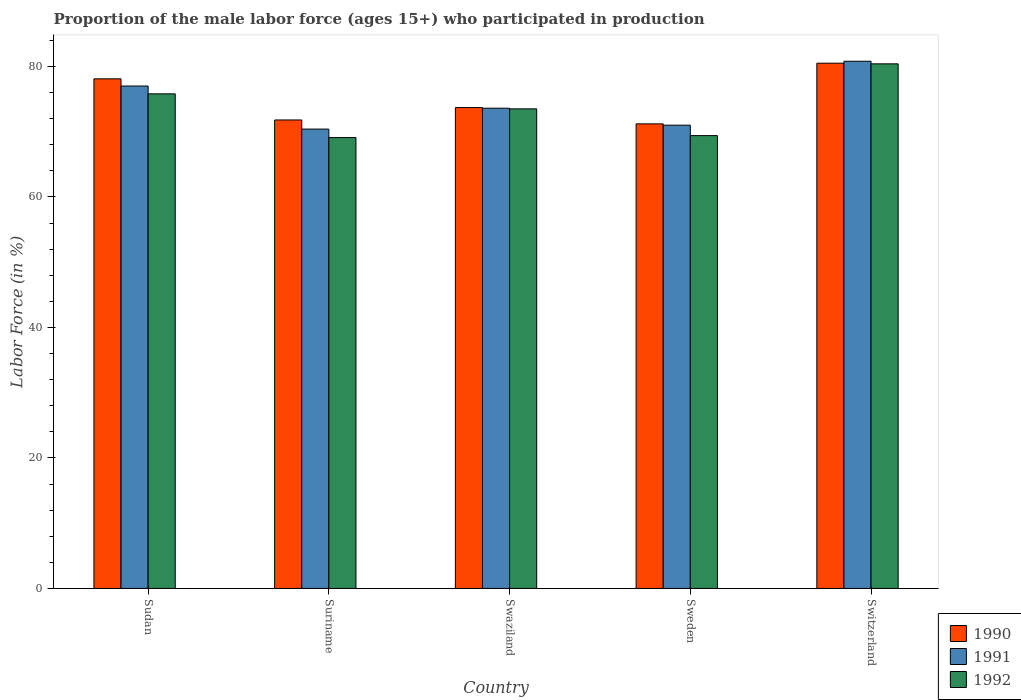How many different coloured bars are there?
Your answer should be very brief. 3. Are the number of bars per tick equal to the number of legend labels?
Offer a terse response. Yes. How many bars are there on the 3rd tick from the right?
Give a very brief answer. 3. What is the label of the 4th group of bars from the left?
Offer a terse response. Sweden. What is the proportion of the male labor force who participated in production in 1991 in Swaziland?
Your answer should be very brief. 73.6. Across all countries, what is the maximum proportion of the male labor force who participated in production in 1991?
Provide a short and direct response. 80.8. Across all countries, what is the minimum proportion of the male labor force who participated in production in 1991?
Give a very brief answer. 70.4. In which country was the proportion of the male labor force who participated in production in 1990 maximum?
Your response must be concise. Switzerland. In which country was the proportion of the male labor force who participated in production in 1991 minimum?
Your answer should be compact. Suriname. What is the total proportion of the male labor force who participated in production in 1992 in the graph?
Give a very brief answer. 368.2. What is the difference between the proportion of the male labor force who participated in production in 1991 in Swaziland and that in Sweden?
Provide a short and direct response. 2.6. What is the difference between the proportion of the male labor force who participated in production in 1990 in Suriname and the proportion of the male labor force who participated in production in 1991 in Sudan?
Your answer should be very brief. -5.2. What is the average proportion of the male labor force who participated in production in 1991 per country?
Your response must be concise. 74.56. What is the difference between the proportion of the male labor force who participated in production of/in 1991 and proportion of the male labor force who participated in production of/in 1992 in Sweden?
Offer a terse response. 1.6. What is the ratio of the proportion of the male labor force who participated in production in 1990 in Swaziland to that in Switzerland?
Make the answer very short. 0.92. Is the proportion of the male labor force who participated in production in 1992 in Swaziland less than that in Switzerland?
Offer a terse response. Yes. What is the difference between the highest and the second highest proportion of the male labor force who participated in production in 1990?
Your answer should be compact. 6.8. What is the difference between the highest and the lowest proportion of the male labor force who participated in production in 1991?
Your answer should be very brief. 10.4. What does the 2nd bar from the left in Sweden represents?
Provide a succinct answer. 1991. What does the 1st bar from the right in Suriname represents?
Ensure brevity in your answer.  1992. How many bars are there?
Your response must be concise. 15. Are all the bars in the graph horizontal?
Keep it short and to the point. No. How many countries are there in the graph?
Keep it short and to the point. 5. Where does the legend appear in the graph?
Ensure brevity in your answer.  Bottom right. What is the title of the graph?
Make the answer very short. Proportion of the male labor force (ages 15+) who participated in production. What is the label or title of the X-axis?
Your answer should be compact. Country. What is the label or title of the Y-axis?
Provide a short and direct response. Labor Force (in %). What is the Labor Force (in %) of 1990 in Sudan?
Make the answer very short. 78.1. What is the Labor Force (in %) in 1991 in Sudan?
Your answer should be compact. 77. What is the Labor Force (in %) in 1992 in Sudan?
Give a very brief answer. 75.8. What is the Labor Force (in %) in 1990 in Suriname?
Keep it short and to the point. 71.8. What is the Labor Force (in %) in 1991 in Suriname?
Provide a short and direct response. 70.4. What is the Labor Force (in %) in 1992 in Suriname?
Keep it short and to the point. 69.1. What is the Labor Force (in %) of 1990 in Swaziland?
Provide a succinct answer. 73.7. What is the Labor Force (in %) of 1991 in Swaziland?
Give a very brief answer. 73.6. What is the Labor Force (in %) in 1992 in Swaziland?
Your answer should be compact. 73.5. What is the Labor Force (in %) in 1990 in Sweden?
Offer a terse response. 71.2. What is the Labor Force (in %) in 1991 in Sweden?
Ensure brevity in your answer.  71. What is the Labor Force (in %) of 1992 in Sweden?
Offer a very short reply. 69.4. What is the Labor Force (in %) of 1990 in Switzerland?
Your answer should be very brief. 80.5. What is the Labor Force (in %) in 1991 in Switzerland?
Your answer should be very brief. 80.8. What is the Labor Force (in %) of 1992 in Switzerland?
Provide a short and direct response. 80.4. Across all countries, what is the maximum Labor Force (in %) of 1990?
Your response must be concise. 80.5. Across all countries, what is the maximum Labor Force (in %) in 1991?
Provide a succinct answer. 80.8. Across all countries, what is the maximum Labor Force (in %) in 1992?
Offer a terse response. 80.4. Across all countries, what is the minimum Labor Force (in %) of 1990?
Offer a very short reply. 71.2. Across all countries, what is the minimum Labor Force (in %) of 1991?
Ensure brevity in your answer.  70.4. Across all countries, what is the minimum Labor Force (in %) of 1992?
Make the answer very short. 69.1. What is the total Labor Force (in %) of 1990 in the graph?
Your answer should be very brief. 375.3. What is the total Labor Force (in %) of 1991 in the graph?
Make the answer very short. 372.8. What is the total Labor Force (in %) of 1992 in the graph?
Your response must be concise. 368.2. What is the difference between the Labor Force (in %) in 1990 in Sudan and that in Suriname?
Ensure brevity in your answer.  6.3. What is the difference between the Labor Force (in %) in 1990 in Sudan and that in Swaziland?
Give a very brief answer. 4.4. What is the difference between the Labor Force (in %) in 1991 in Sudan and that in Switzerland?
Your response must be concise. -3.8. What is the difference between the Labor Force (in %) in 1992 in Sudan and that in Switzerland?
Offer a terse response. -4.6. What is the difference between the Labor Force (in %) of 1990 in Suriname and that in Swaziland?
Keep it short and to the point. -1.9. What is the difference between the Labor Force (in %) in 1991 in Suriname and that in Swaziland?
Keep it short and to the point. -3.2. What is the difference between the Labor Force (in %) in 1992 in Suriname and that in Swaziland?
Provide a short and direct response. -4.4. What is the difference between the Labor Force (in %) in 1990 in Suriname and that in Sweden?
Offer a very short reply. 0.6. What is the difference between the Labor Force (in %) in 1991 in Suriname and that in Sweden?
Make the answer very short. -0.6. What is the difference between the Labor Force (in %) of 1992 in Suriname and that in Sweden?
Make the answer very short. -0.3. What is the difference between the Labor Force (in %) in 1990 in Suriname and that in Switzerland?
Your answer should be very brief. -8.7. What is the difference between the Labor Force (in %) in 1991 in Suriname and that in Switzerland?
Ensure brevity in your answer.  -10.4. What is the difference between the Labor Force (in %) of 1992 in Swaziland and that in Switzerland?
Offer a terse response. -6.9. What is the difference between the Labor Force (in %) in 1990 in Sweden and that in Switzerland?
Your answer should be very brief. -9.3. What is the difference between the Labor Force (in %) of 1992 in Sweden and that in Switzerland?
Your answer should be compact. -11. What is the difference between the Labor Force (in %) of 1990 in Sudan and the Labor Force (in %) of 1991 in Suriname?
Offer a very short reply. 7.7. What is the difference between the Labor Force (in %) of 1990 in Sudan and the Labor Force (in %) of 1992 in Suriname?
Your answer should be compact. 9. What is the difference between the Labor Force (in %) in 1990 in Sudan and the Labor Force (in %) in 1991 in Swaziland?
Offer a very short reply. 4.5. What is the difference between the Labor Force (in %) in 1990 in Sudan and the Labor Force (in %) in 1992 in Swaziland?
Provide a succinct answer. 4.6. What is the difference between the Labor Force (in %) of 1990 in Sudan and the Labor Force (in %) of 1991 in Sweden?
Provide a succinct answer. 7.1. What is the difference between the Labor Force (in %) in 1990 in Sudan and the Labor Force (in %) in 1992 in Sweden?
Provide a short and direct response. 8.7. What is the difference between the Labor Force (in %) in 1991 in Sudan and the Labor Force (in %) in 1992 in Sweden?
Offer a very short reply. 7.6. What is the difference between the Labor Force (in %) in 1990 in Sudan and the Labor Force (in %) in 1991 in Switzerland?
Ensure brevity in your answer.  -2.7. What is the difference between the Labor Force (in %) of 1990 in Suriname and the Labor Force (in %) of 1992 in Swaziland?
Offer a very short reply. -1.7. What is the difference between the Labor Force (in %) of 1991 in Suriname and the Labor Force (in %) of 1992 in Swaziland?
Your response must be concise. -3.1. What is the difference between the Labor Force (in %) in 1991 in Suriname and the Labor Force (in %) in 1992 in Sweden?
Your response must be concise. 1. What is the difference between the Labor Force (in %) of 1990 in Swaziland and the Labor Force (in %) of 1992 in Sweden?
Ensure brevity in your answer.  4.3. What is the difference between the Labor Force (in %) in 1991 in Swaziland and the Labor Force (in %) in 1992 in Sweden?
Make the answer very short. 4.2. What is the difference between the Labor Force (in %) of 1990 in Swaziland and the Labor Force (in %) of 1991 in Switzerland?
Provide a succinct answer. -7.1. What is the difference between the Labor Force (in %) in 1991 in Swaziland and the Labor Force (in %) in 1992 in Switzerland?
Your answer should be very brief. -6.8. What is the difference between the Labor Force (in %) of 1990 in Sweden and the Labor Force (in %) of 1991 in Switzerland?
Offer a very short reply. -9.6. What is the difference between the Labor Force (in %) in 1991 in Sweden and the Labor Force (in %) in 1992 in Switzerland?
Keep it short and to the point. -9.4. What is the average Labor Force (in %) of 1990 per country?
Give a very brief answer. 75.06. What is the average Labor Force (in %) in 1991 per country?
Provide a short and direct response. 74.56. What is the average Labor Force (in %) of 1992 per country?
Your answer should be compact. 73.64. What is the difference between the Labor Force (in %) in 1990 and Labor Force (in %) in 1992 in Sudan?
Offer a very short reply. 2.3. What is the difference between the Labor Force (in %) in 1990 and Labor Force (in %) in 1991 in Suriname?
Your answer should be very brief. 1.4. What is the difference between the Labor Force (in %) of 1990 and Labor Force (in %) of 1992 in Suriname?
Your answer should be compact. 2.7. What is the difference between the Labor Force (in %) in 1991 and Labor Force (in %) in 1992 in Suriname?
Provide a short and direct response. 1.3. What is the difference between the Labor Force (in %) of 1991 and Labor Force (in %) of 1992 in Swaziland?
Your answer should be compact. 0.1. What is the difference between the Labor Force (in %) of 1990 and Labor Force (in %) of 1992 in Sweden?
Provide a succinct answer. 1.8. What is the difference between the Labor Force (in %) in 1990 and Labor Force (in %) in 1991 in Switzerland?
Your answer should be compact. -0.3. What is the ratio of the Labor Force (in %) of 1990 in Sudan to that in Suriname?
Offer a terse response. 1.09. What is the ratio of the Labor Force (in %) of 1991 in Sudan to that in Suriname?
Your answer should be very brief. 1.09. What is the ratio of the Labor Force (in %) in 1992 in Sudan to that in Suriname?
Provide a short and direct response. 1.1. What is the ratio of the Labor Force (in %) of 1990 in Sudan to that in Swaziland?
Ensure brevity in your answer.  1.06. What is the ratio of the Labor Force (in %) of 1991 in Sudan to that in Swaziland?
Offer a very short reply. 1.05. What is the ratio of the Labor Force (in %) of 1992 in Sudan to that in Swaziland?
Ensure brevity in your answer.  1.03. What is the ratio of the Labor Force (in %) in 1990 in Sudan to that in Sweden?
Your answer should be compact. 1.1. What is the ratio of the Labor Force (in %) of 1991 in Sudan to that in Sweden?
Ensure brevity in your answer.  1.08. What is the ratio of the Labor Force (in %) of 1992 in Sudan to that in Sweden?
Give a very brief answer. 1.09. What is the ratio of the Labor Force (in %) of 1990 in Sudan to that in Switzerland?
Your answer should be compact. 0.97. What is the ratio of the Labor Force (in %) of 1991 in Sudan to that in Switzerland?
Ensure brevity in your answer.  0.95. What is the ratio of the Labor Force (in %) in 1992 in Sudan to that in Switzerland?
Provide a succinct answer. 0.94. What is the ratio of the Labor Force (in %) in 1990 in Suriname to that in Swaziland?
Offer a very short reply. 0.97. What is the ratio of the Labor Force (in %) in 1991 in Suriname to that in Swaziland?
Offer a very short reply. 0.96. What is the ratio of the Labor Force (in %) in 1992 in Suriname to that in Swaziland?
Keep it short and to the point. 0.94. What is the ratio of the Labor Force (in %) in 1990 in Suriname to that in Sweden?
Make the answer very short. 1.01. What is the ratio of the Labor Force (in %) of 1992 in Suriname to that in Sweden?
Offer a very short reply. 1. What is the ratio of the Labor Force (in %) in 1990 in Suriname to that in Switzerland?
Offer a very short reply. 0.89. What is the ratio of the Labor Force (in %) in 1991 in Suriname to that in Switzerland?
Give a very brief answer. 0.87. What is the ratio of the Labor Force (in %) of 1992 in Suriname to that in Switzerland?
Your answer should be compact. 0.86. What is the ratio of the Labor Force (in %) of 1990 in Swaziland to that in Sweden?
Your answer should be very brief. 1.04. What is the ratio of the Labor Force (in %) in 1991 in Swaziland to that in Sweden?
Your answer should be compact. 1.04. What is the ratio of the Labor Force (in %) in 1992 in Swaziland to that in Sweden?
Provide a succinct answer. 1.06. What is the ratio of the Labor Force (in %) in 1990 in Swaziland to that in Switzerland?
Ensure brevity in your answer.  0.92. What is the ratio of the Labor Force (in %) of 1991 in Swaziland to that in Switzerland?
Provide a short and direct response. 0.91. What is the ratio of the Labor Force (in %) in 1992 in Swaziland to that in Switzerland?
Keep it short and to the point. 0.91. What is the ratio of the Labor Force (in %) in 1990 in Sweden to that in Switzerland?
Provide a short and direct response. 0.88. What is the ratio of the Labor Force (in %) in 1991 in Sweden to that in Switzerland?
Provide a succinct answer. 0.88. What is the ratio of the Labor Force (in %) of 1992 in Sweden to that in Switzerland?
Offer a very short reply. 0.86. What is the difference between the highest and the second highest Labor Force (in %) of 1992?
Your answer should be very brief. 4.6. What is the difference between the highest and the lowest Labor Force (in %) of 1990?
Offer a very short reply. 9.3. What is the difference between the highest and the lowest Labor Force (in %) of 1991?
Offer a very short reply. 10.4. 